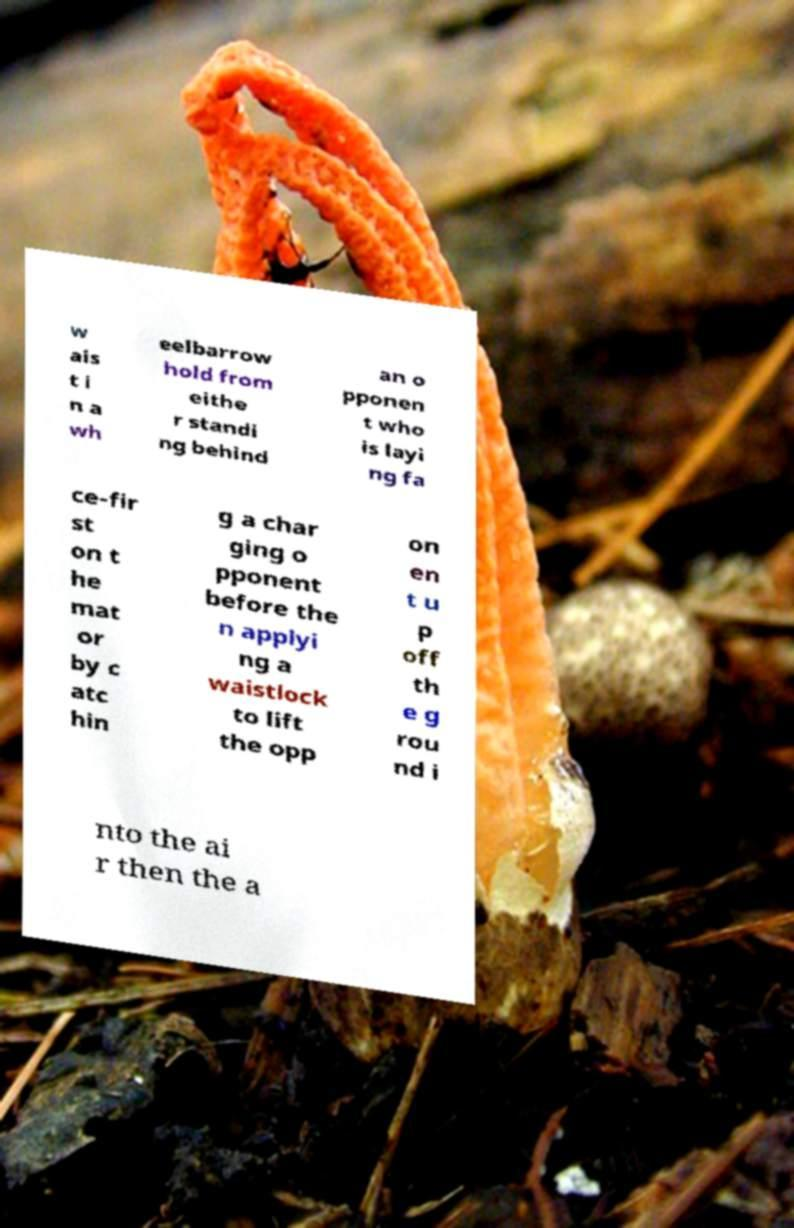What messages or text are displayed in this image? I need them in a readable, typed format. w ais t i n a wh eelbarrow hold from eithe r standi ng behind an o pponen t who is layi ng fa ce-fir st on t he mat or by c atc hin g a char ging o pponent before the n applyi ng a waistlock to lift the opp on en t u p off th e g rou nd i nto the ai r then the a 